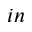<formula> <loc_0><loc_0><loc_500><loc_500>_ { i n }</formula> 